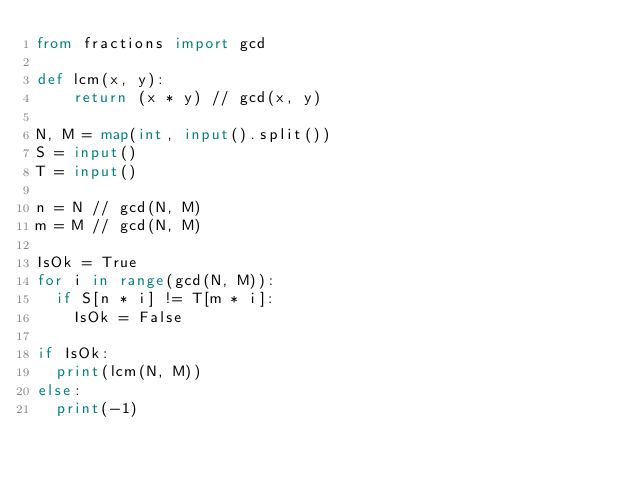<code> <loc_0><loc_0><loc_500><loc_500><_Python_>from fractions import gcd

def lcm(x, y):
    return (x * y) // gcd(x, y)

N, M = map(int, input().split()) 
S = input()
T = input()

n = N // gcd(N, M)
m = M // gcd(N, M)

IsOk = True
for i in range(gcd(N, M)):
  if S[n * i] != T[m * i]:
    IsOk = False

if IsOk:
  print(lcm(N, M))
else:
  print(-1)
</code> 